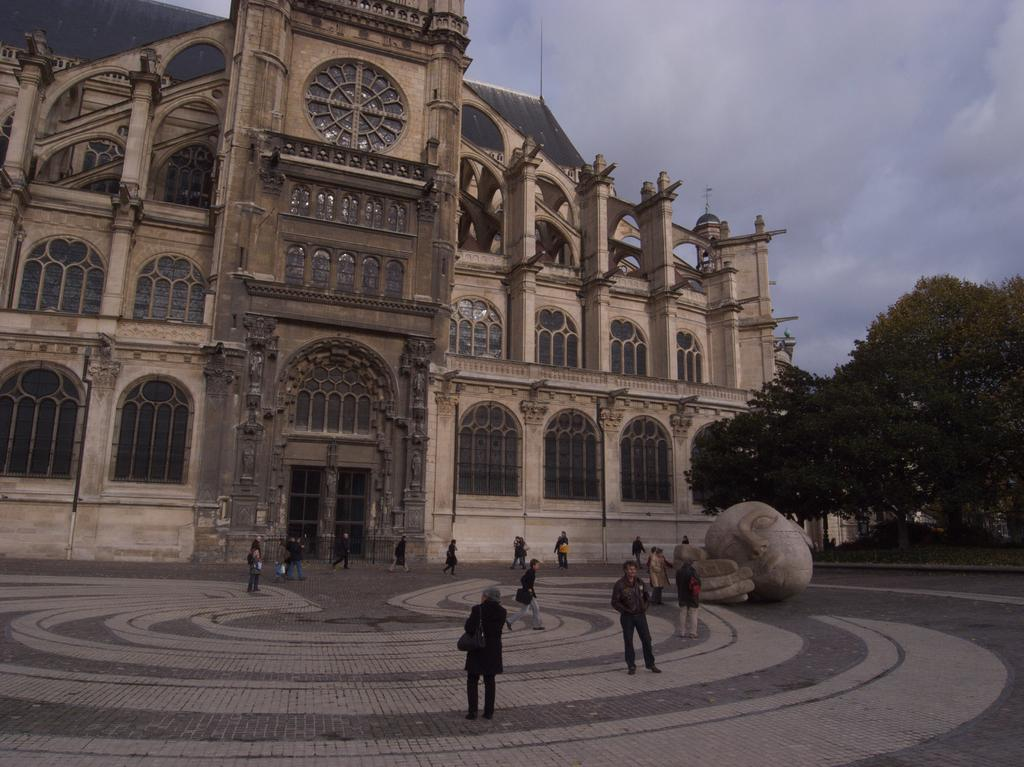What is the main structure in the picture? There is a building in the picture. What feature can be seen on the building? The building has windows. What other object is present in the picture? There is a statue in the picture. What is happening with the people in the picture? There are people walking in the picture. What type of vegetation is on the right side of the picture? There are trees on the right side of the picture. What is the condition of the sky in the picture? The sky is clear in the picture. What type of drop can be seen falling from the statue in the picture? There is no drop falling from the statue in the picture. What discovery was made at the location of the building in the picture? There is no information about any discovery made at the location of the building in the picture. 